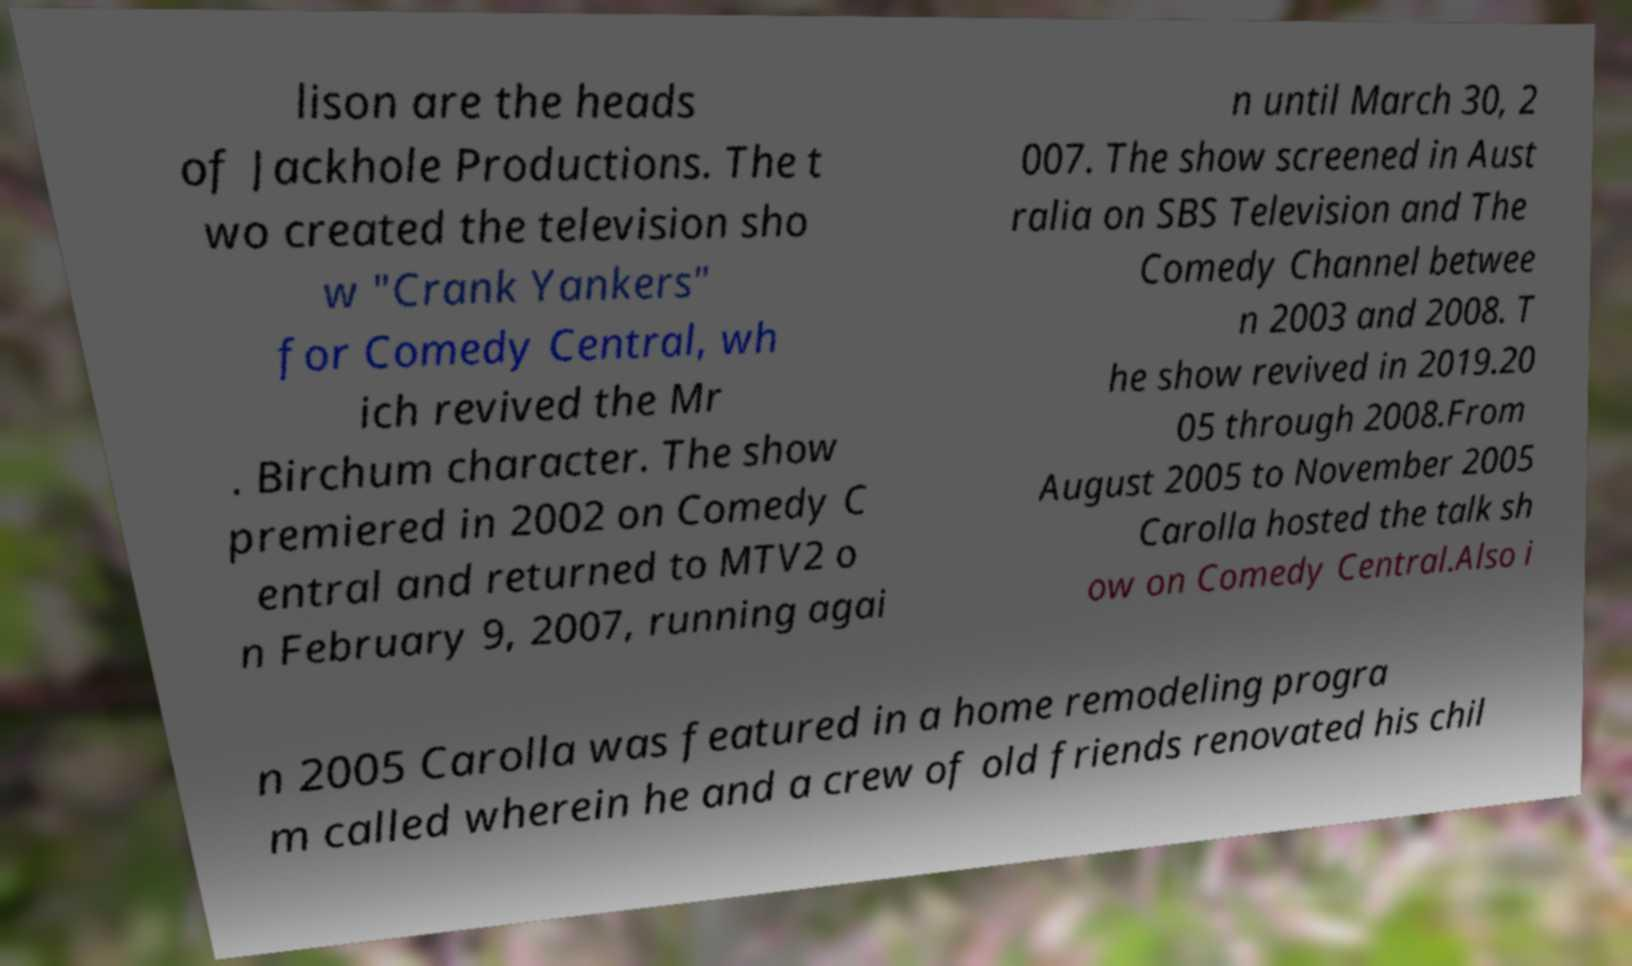Can you accurately transcribe the text from the provided image for me? lison are the heads of Jackhole Productions. The t wo created the television sho w "Crank Yankers" for Comedy Central, wh ich revived the Mr . Birchum character. The show premiered in 2002 on Comedy C entral and returned to MTV2 o n February 9, 2007, running agai n until March 30, 2 007. The show screened in Aust ralia on SBS Television and The Comedy Channel betwee n 2003 and 2008. T he show revived in 2019.20 05 through 2008.From August 2005 to November 2005 Carolla hosted the talk sh ow on Comedy Central.Also i n 2005 Carolla was featured in a home remodeling progra m called wherein he and a crew of old friends renovated his chil 